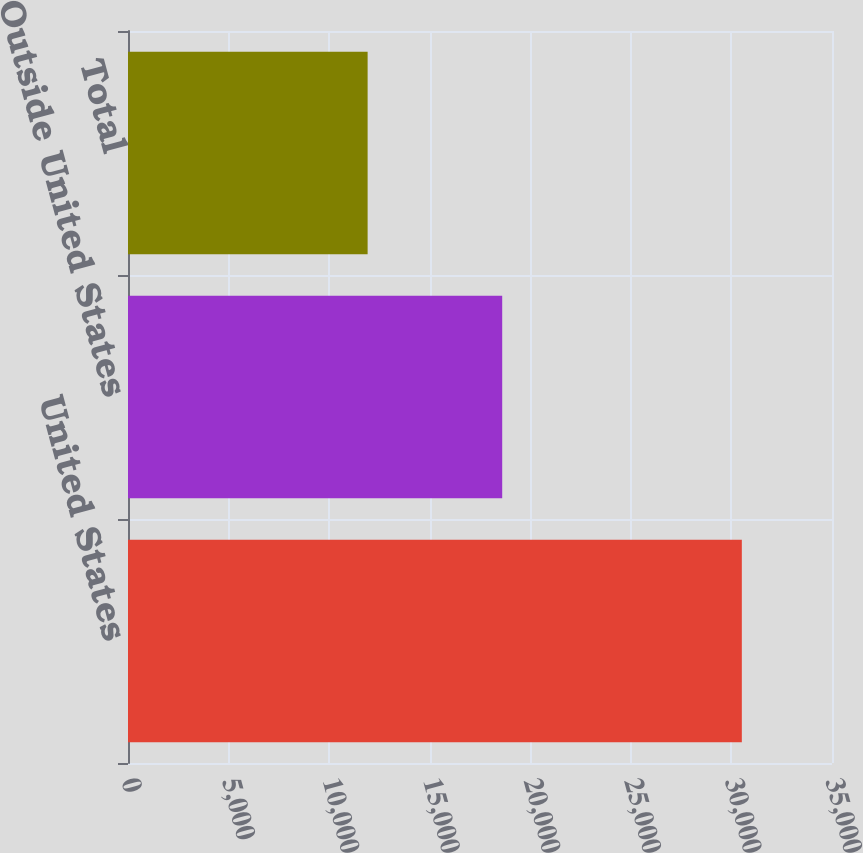<chart> <loc_0><loc_0><loc_500><loc_500><bar_chart><fcel>United States<fcel>Outside United States<fcel>Total<nl><fcel>30517<fcel>18604<fcel>11913<nl></chart> 